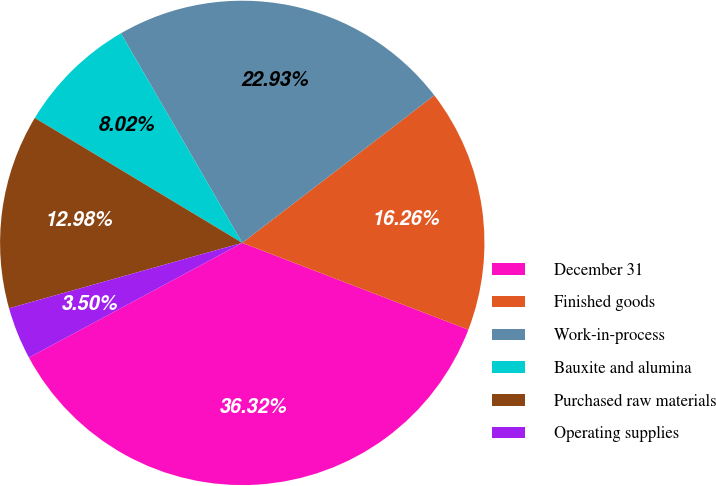<chart> <loc_0><loc_0><loc_500><loc_500><pie_chart><fcel>December 31<fcel>Finished goods<fcel>Work-in-process<fcel>Bauxite and alumina<fcel>Purchased raw materials<fcel>Operating supplies<nl><fcel>36.32%<fcel>16.26%<fcel>22.93%<fcel>8.02%<fcel>12.98%<fcel>3.5%<nl></chart> 